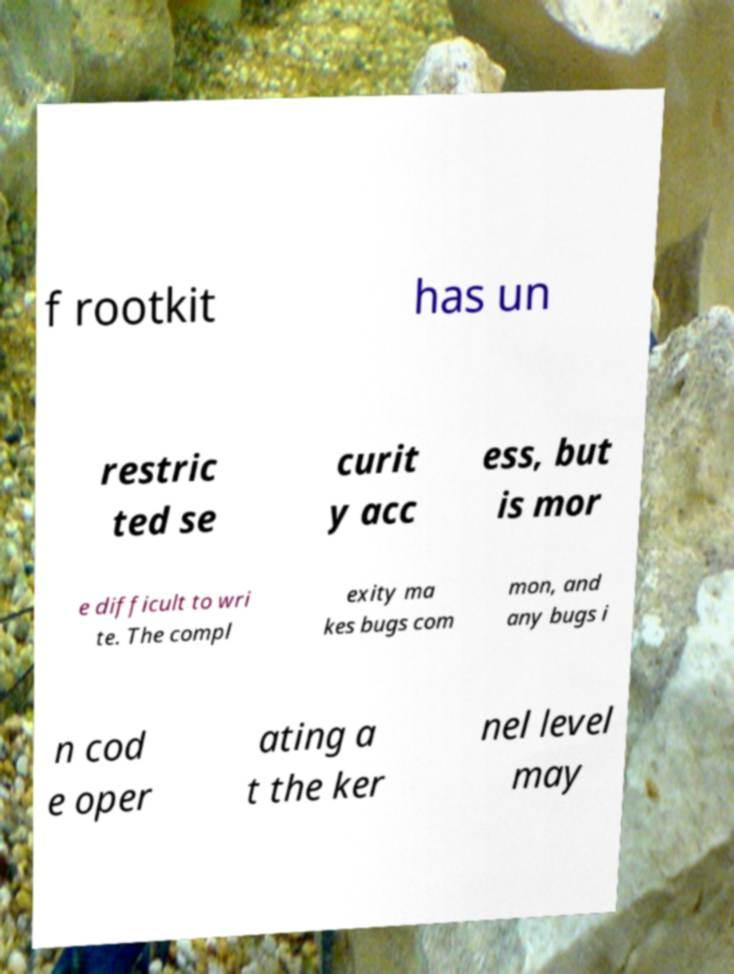For documentation purposes, I need the text within this image transcribed. Could you provide that? f rootkit has un restric ted se curit y acc ess, but is mor e difficult to wri te. The compl exity ma kes bugs com mon, and any bugs i n cod e oper ating a t the ker nel level may 